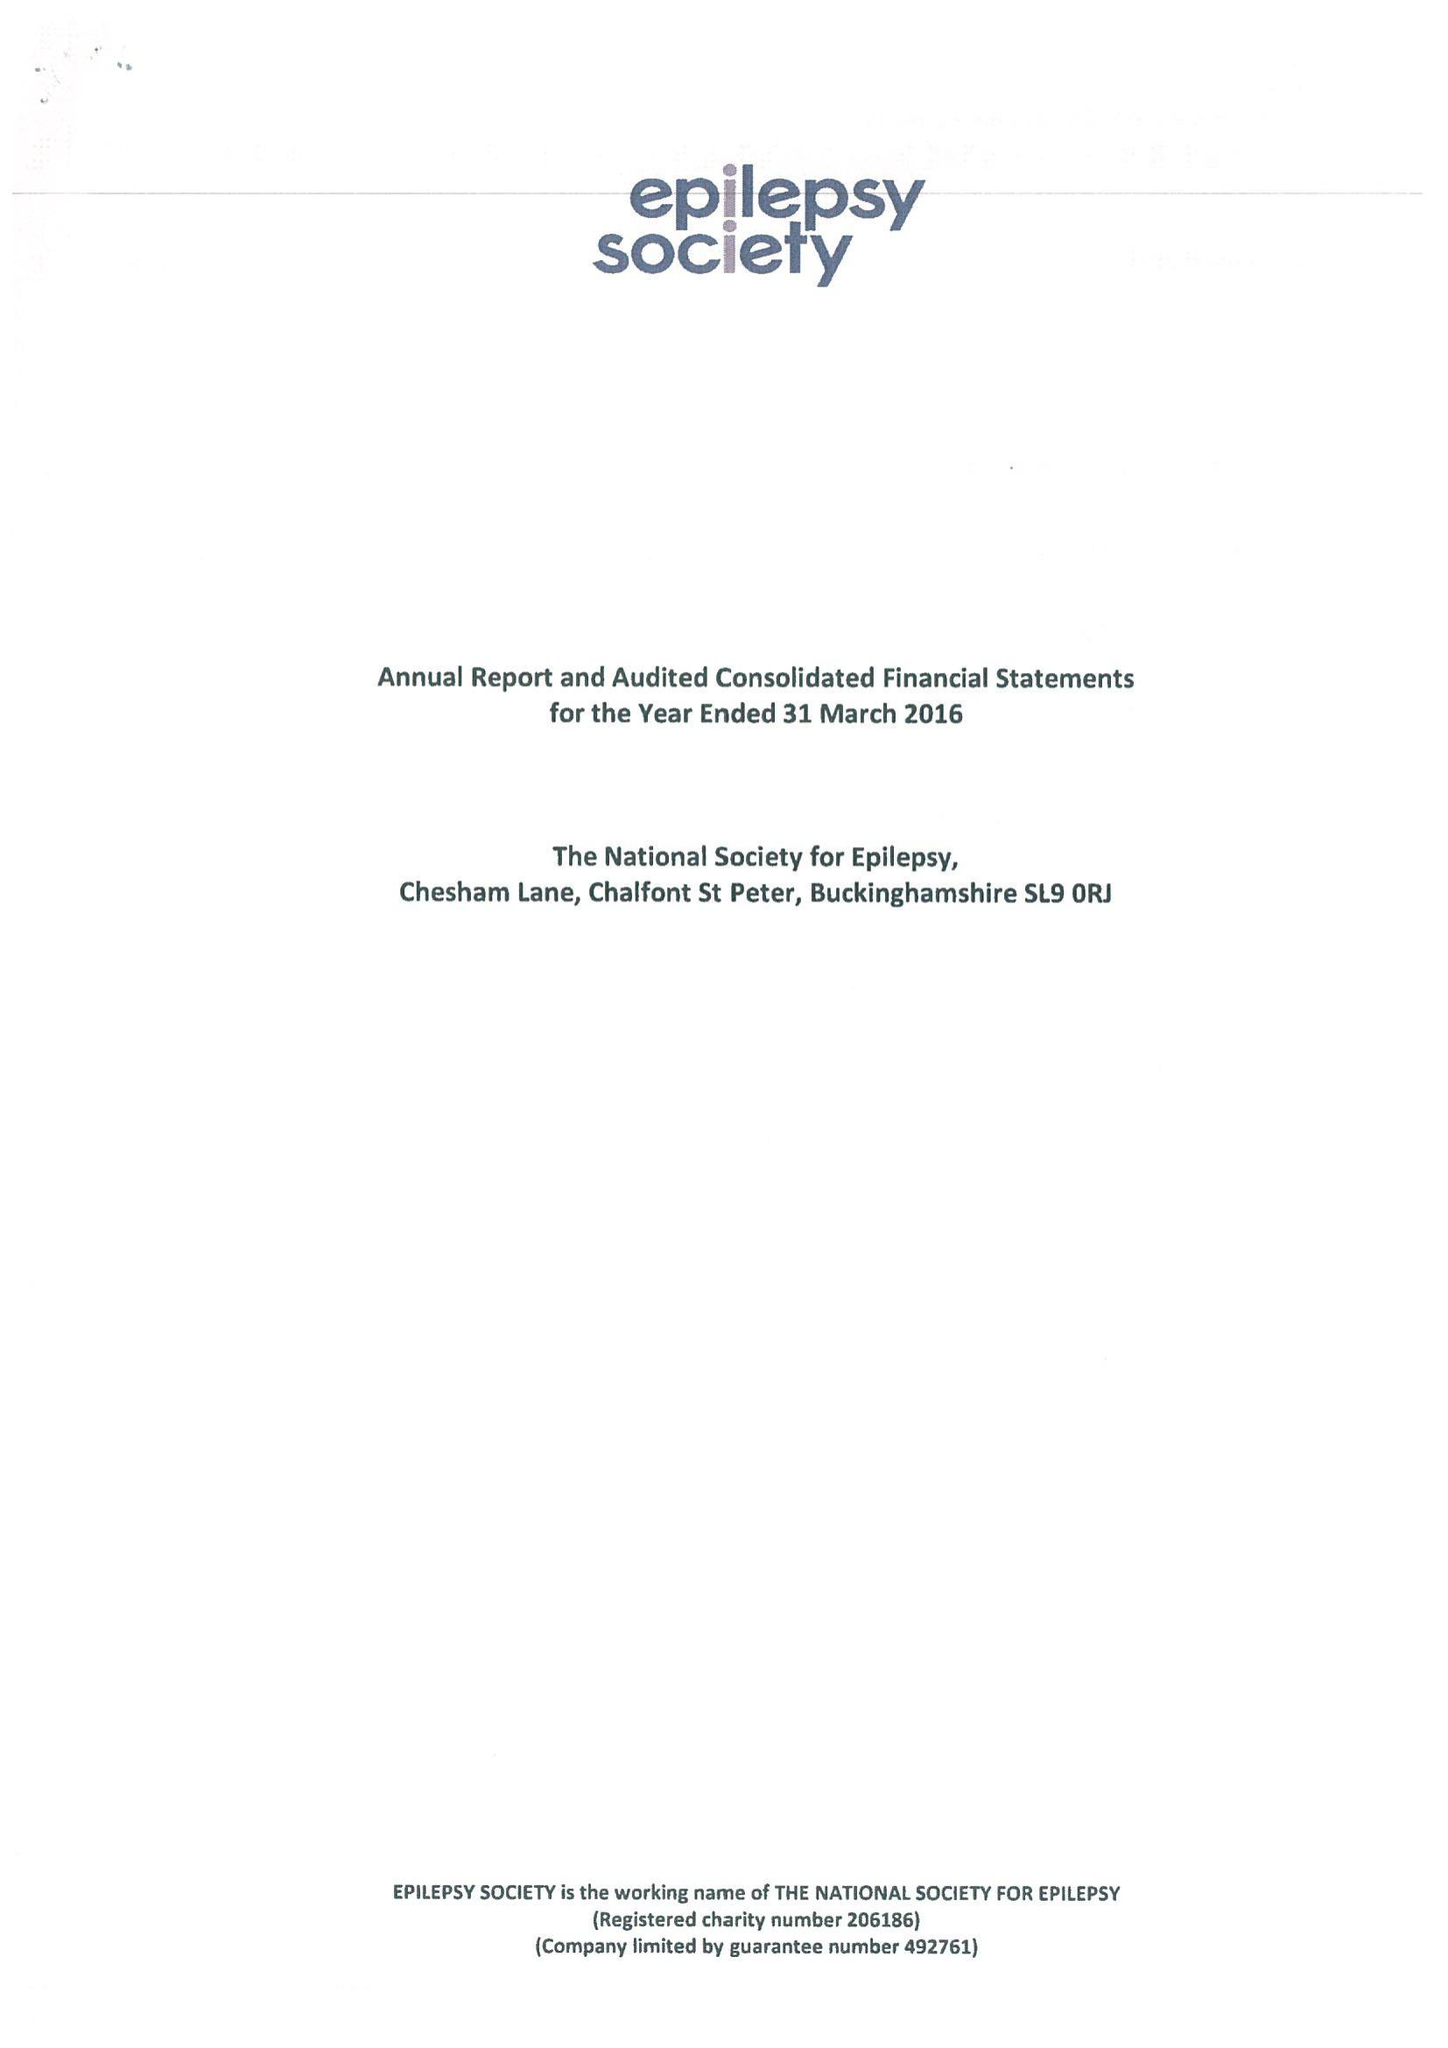What is the value for the report_date?
Answer the question using a single word or phrase. 2016-03-31 